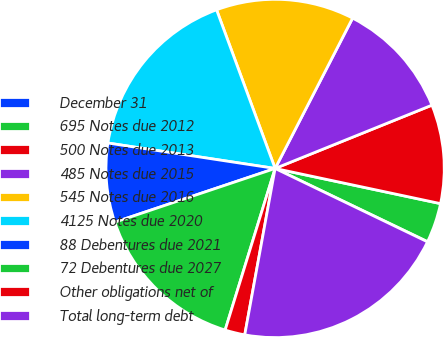<chart> <loc_0><loc_0><loc_500><loc_500><pie_chart><fcel>December 31<fcel>695 Notes due 2012<fcel>500 Notes due 2013<fcel>485 Notes due 2015<fcel>545 Notes due 2016<fcel>4125 Notes due 2020<fcel>88 Debentures due 2021<fcel>72 Debentures due 2027<fcel>Other obligations net of<fcel>Total long-term debt<nl><fcel>0.02%<fcel>3.79%<fcel>9.44%<fcel>11.32%<fcel>13.2%<fcel>16.97%<fcel>7.55%<fcel>15.08%<fcel>1.9%<fcel>20.73%<nl></chart> 